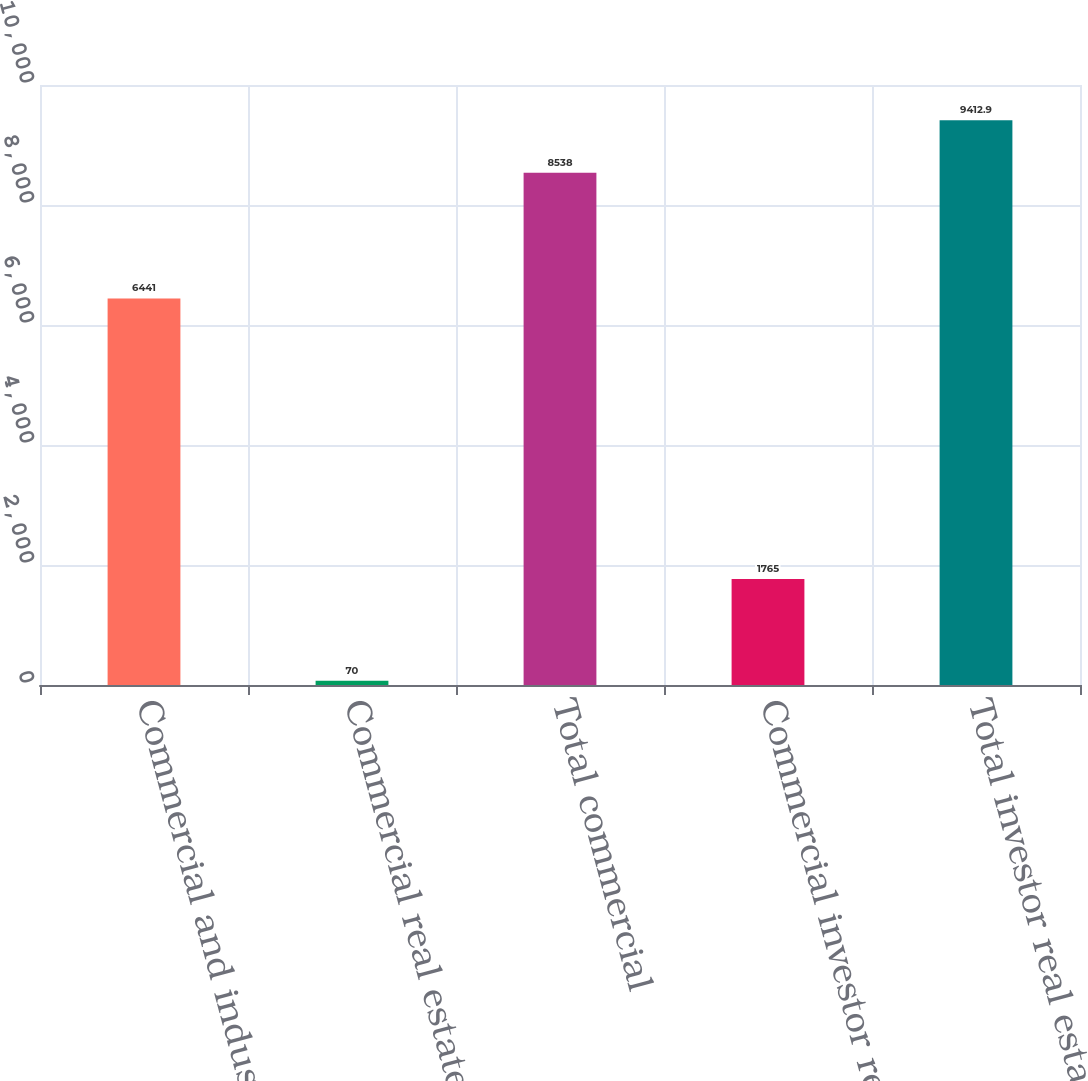Convert chart to OTSL. <chart><loc_0><loc_0><loc_500><loc_500><bar_chart><fcel>Commercial and industrial<fcel>Commercial real estate<fcel>Total commercial<fcel>Commercial investor real<fcel>Total investor real estate<nl><fcel>6441<fcel>70<fcel>8538<fcel>1765<fcel>9412.9<nl></chart> 